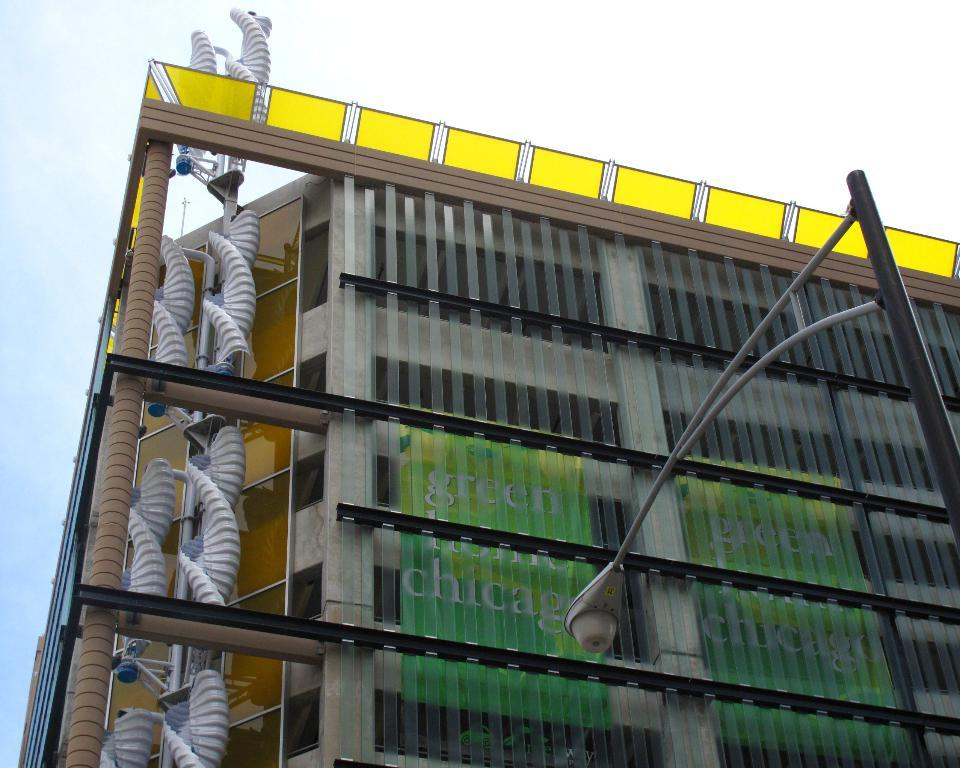What type of structure is present in the image? There is a building in the image. What other object can be seen near the building? There is a light pole in the image. Are there any additional features visible in the image? Yes, there are pipes in the image. What can be seen in the background of the image? The sky is visible in the background of the image. Where is the meeting taking place in the image? There is no meeting present in the image; it only shows a building, a light pole, pipes, and the sky. 